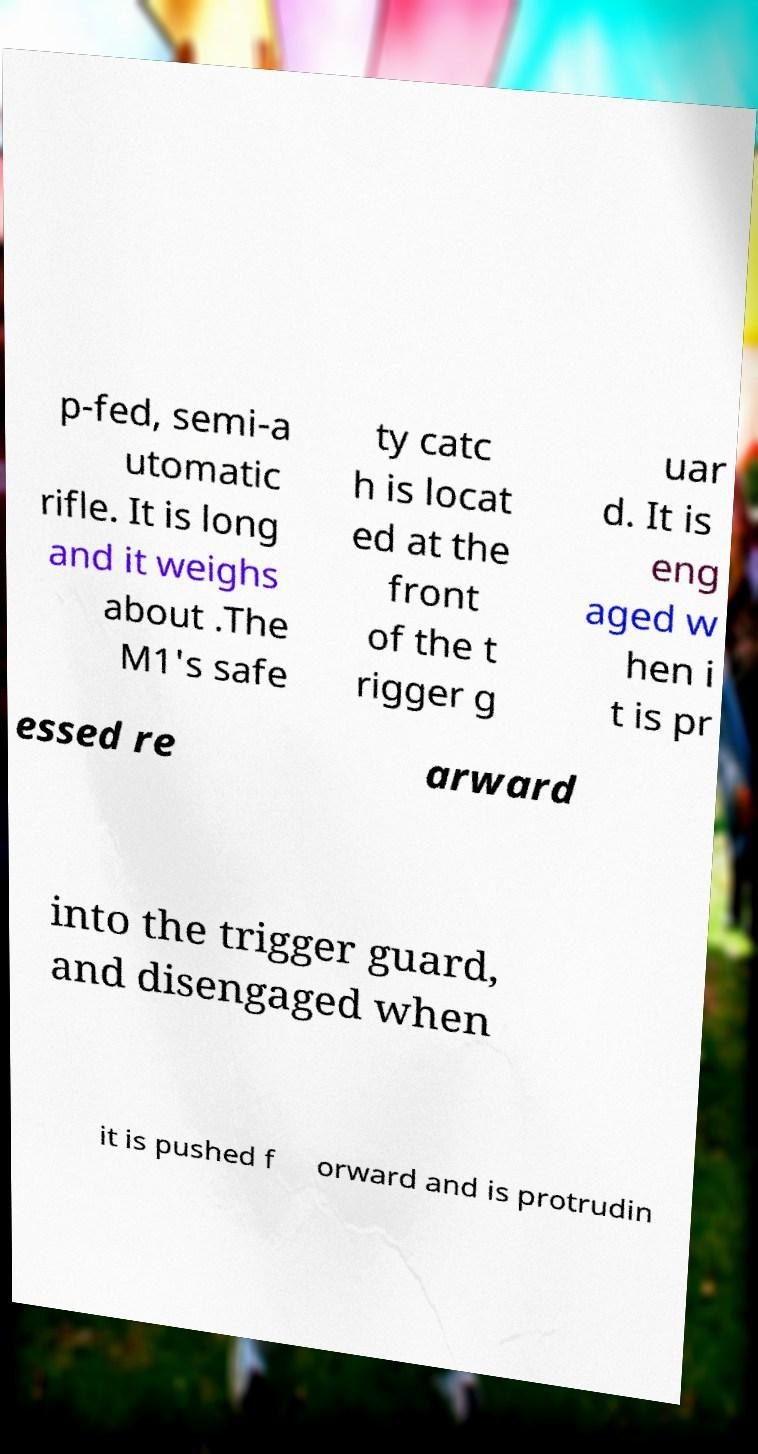Can you accurately transcribe the text from the provided image for me? p-fed, semi-a utomatic rifle. It is long and it weighs about .The M1's safe ty catc h is locat ed at the front of the t rigger g uar d. It is eng aged w hen i t is pr essed re arward into the trigger guard, and disengaged when it is pushed f orward and is protrudin 